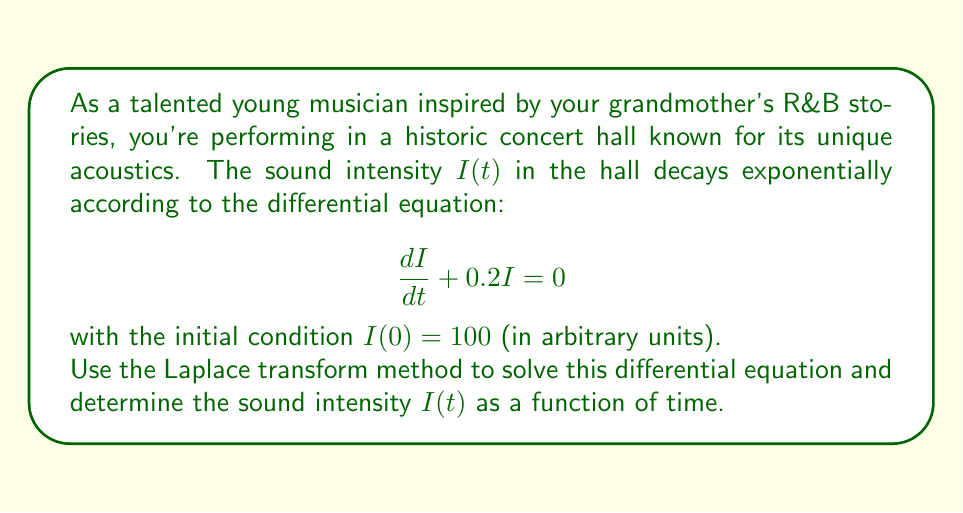What is the answer to this math problem? Let's solve this problem step by step using the Laplace transform method:

1) First, we take the Laplace transform of both sides of the differential equation:

   $$\mathcal{L}\left\{\frac{dI}{dt}\right\} + 0.2\mathcal{L}\{I\} = 0$$

2) Using the Laplace transform property for derivatives:

   $$s\mathcal{L}\{I\} - I(0) + 0.2\mathcal{L}\{I\} = 0$$

3) Let $\mathcal{L}\{I\} = F(s)$. Substituting the initial condition $I(0) = 100$:

   $$sF(s) - 100 + 0.2F(s) = 0$$

4) Factoring out $F(s)$:

   $$(s + 0.2)F(s) = 100$$

5) Solving for $F(s)$:

   $$F(s) = \frac{100}{s + 0.2}$$

6) This can be written as:

   $$F(s) = \frac{100}{s + 0.2}$$

7) We recognize this as the Laplace transform of an exponential function. The inverse Laplace transform gives us:

   $$I(t) = 100e^{-0.2t}$$

This solution represents the decay of sound intensity in the concert hall over time.
Answer: $I(t) = 100e^{-0.2t}$ 